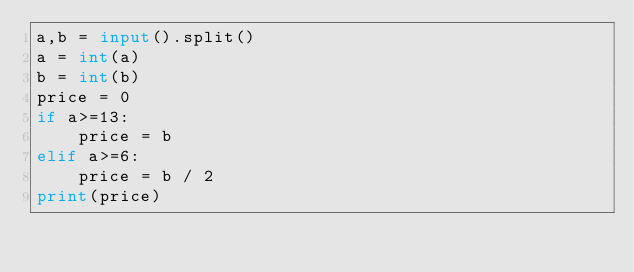<code> <loc_0><loc_0><loc_500><loc_500><_Python_>a,b = input().split()
a = int(a)
b = int(b)
price = 0
if a>=13:
    price = b
elif a>=6:
    price = b / 2
print(price)</code> 